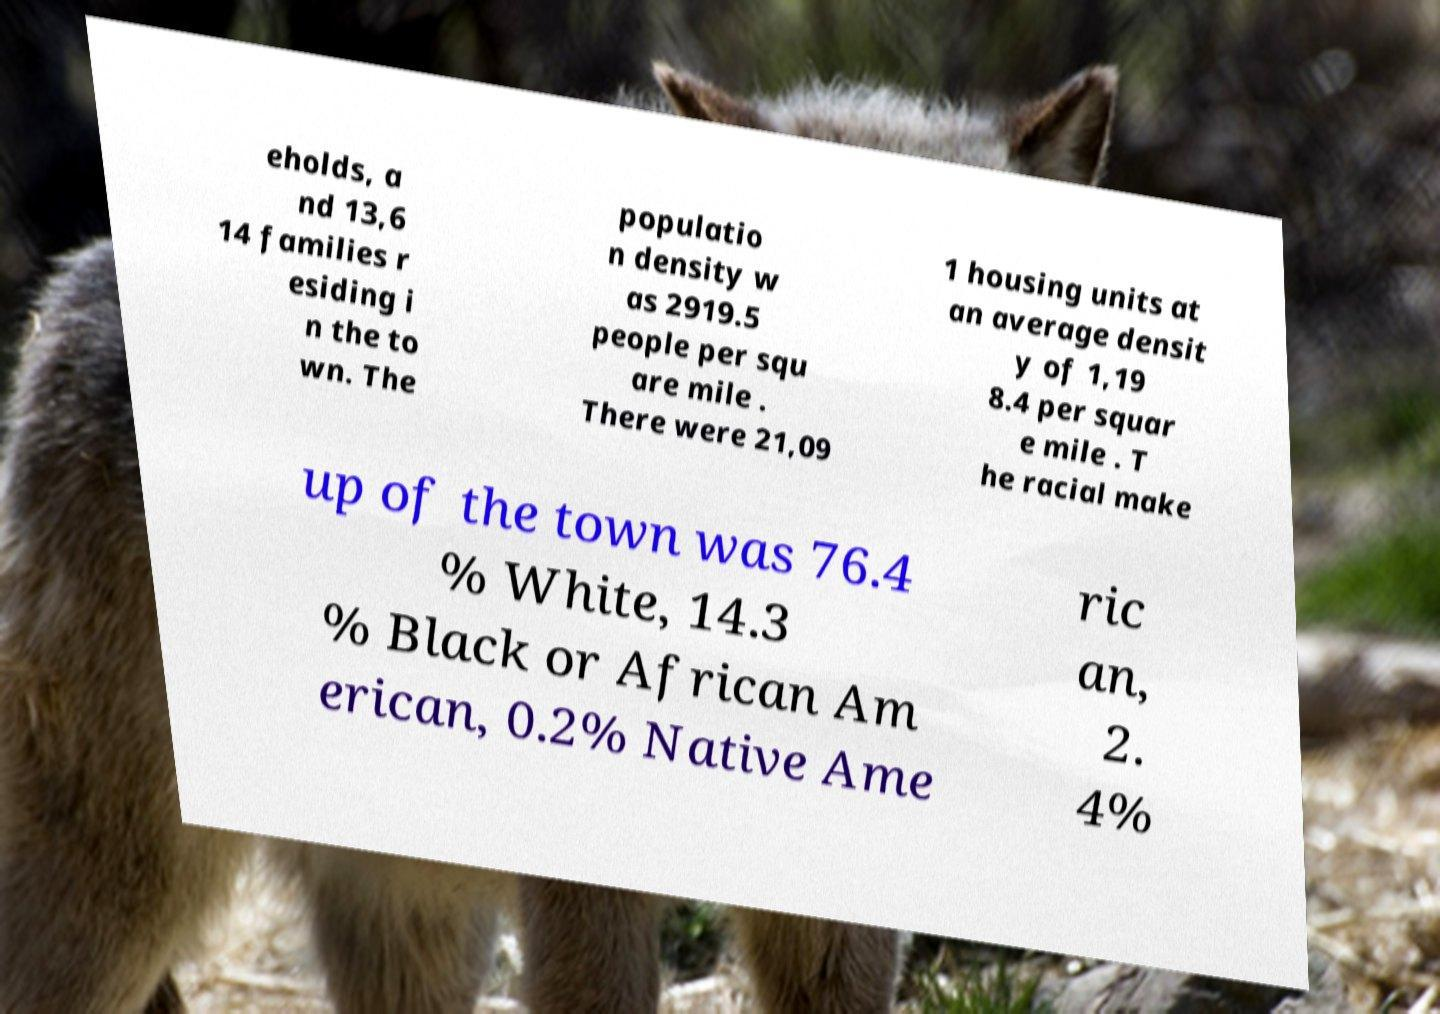Can you read and provide the text displayed in the image?This photo seems to have some interesting text. Can you extract and type it out for me? eholds, a nd 13,6 14 families r esiding i n the to wn. The populatio n density w as 2919.5 people per squ are mile . There were 21,09 1 housing units at an average densit y of 1,19 8.4 per squar e mile . T he racial make up of the town was 76.4 % White, 14.3 % Black or African Am erican, 0.2% Native Ame ric an, 2. 4% 